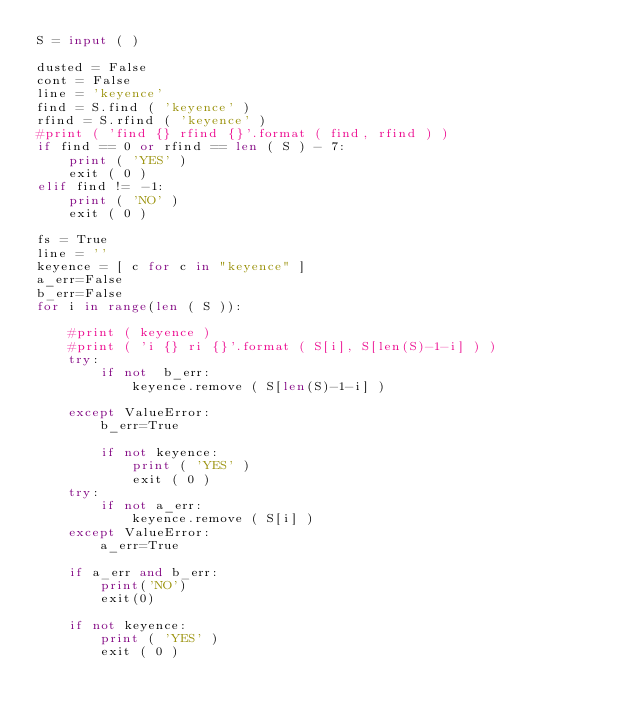<code> <loc_0><loc_0><loc_500><loc_500><_Python_>S = input ( )

dusted = False
cont = False
line = 'keyence'
find = S.find ( 'keyence' )
rfind = S.rfind ( 'keyence' )
#print ( 'find {} rfind {}'.format ( find, rfind ) )
if find == 0 or rfind == len ( S ) - 7:
    print ( 'YES' )
    exit ( 0 )
elif find != -1:
    print ( 'NO' )
    exit ( 0 )

fs = True
line = ''
keyence = [ c for c in "keyence" ]
a_err=False
b_err=False
for i in range(len ( S )):

    #print ( keyence )
    #print ( 'i {} ri {}'.format ( S[i], S[len(S)-1-i] ) )
    try:
        if not  b_err:
            keyence.remove ( S[len(S)-1-i] )

    except ValueError:
        b_err=True

        if not keyence:
            print ( 'YES' )
            exit ( 0 )
    try:
        if not a_err:
            keyence.remove ( S[i] )
    except ValueError:
        a_err=True

    if a_err and b_err:
        print('NO')
        exit(0)

    if not keyence:
        print ( 'YES' )
        exit ( 0 )
</code> 